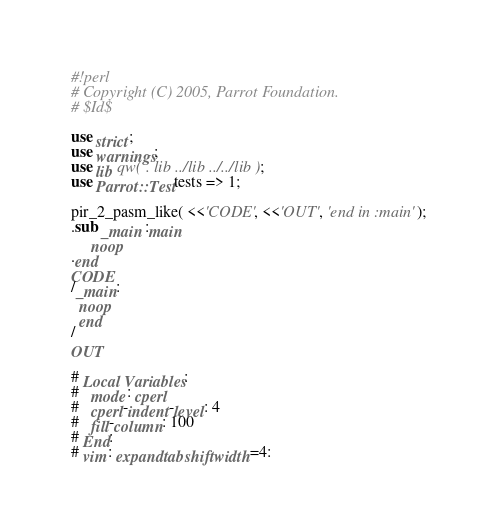<code> <loc_0><loc_0><loc_500><loc_500><_Perl_>#!perl
# Copyright (C) 2005, Parrot Foundation.
# $Id$

use strict;
use warnings;
use lib qw( . lib ../lib ../../lib );
use Parrot::Test tests => 1;

pir_2_pasm_like( <<'CODE', <<'OUT', 'end in :main' );
.sub _main :main
     noop
.end
CODE
/_main:
  noop
  end
/
OUT

# Local Variables:
#   mode: cperl
#   cperl-indent-level: 4
#   fill-column: 100
# End:
# vim: expandtab shiftwidth=4:

</code> 